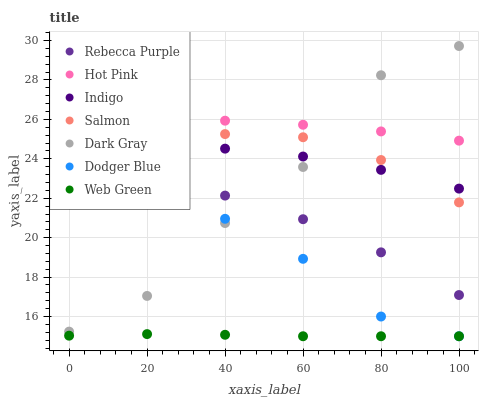Does Web Green have the minimum area under the curve?
Answer yes or no. Yes. Does Hot Pink have the maximum area under the curve?
Answer yes or no. Yes. Does Salmon have the minimum area under the curve?
Answer yes or no. No. Does Salmon have the maximum area under the curve?
Answer yes or no. No. Is Web Green the smoothest?
Answer yes or no. Yes. Is Dark Gray the roughest?
Answer yes or no. Yes. Is Hot Pink the smoothest?
Answer yes or no. No. Is Hot Pink the roughest?
Answer yes or no. No. Does Web Green have the lowest value?
Answer yes or no. Yes. Does Salmon have the lowest value?
Answer yes or no. No. Does Dark Gray have the highest value?
Answer yes or no. Yes. Does Hot Pink have the highest value?
Answer yes or no. No. Is Rebecca Purple less than Hot Pink?
Answer yes or no. Yes. Is Hot Pink greater than Rebecca Purple?
Answer yes or no. Yes. Does Dodger Blue intersect Dark Gray?
Answer yes or no. Yes. Is Dodger Blue less than Dark Gray?
Answer yes or no. No. Is Dodger Blue greater than Dark Gray?
Answer yes or no. No. Does Rebecca Purple intersect Hot Pink?
Answer yes or no. No. 